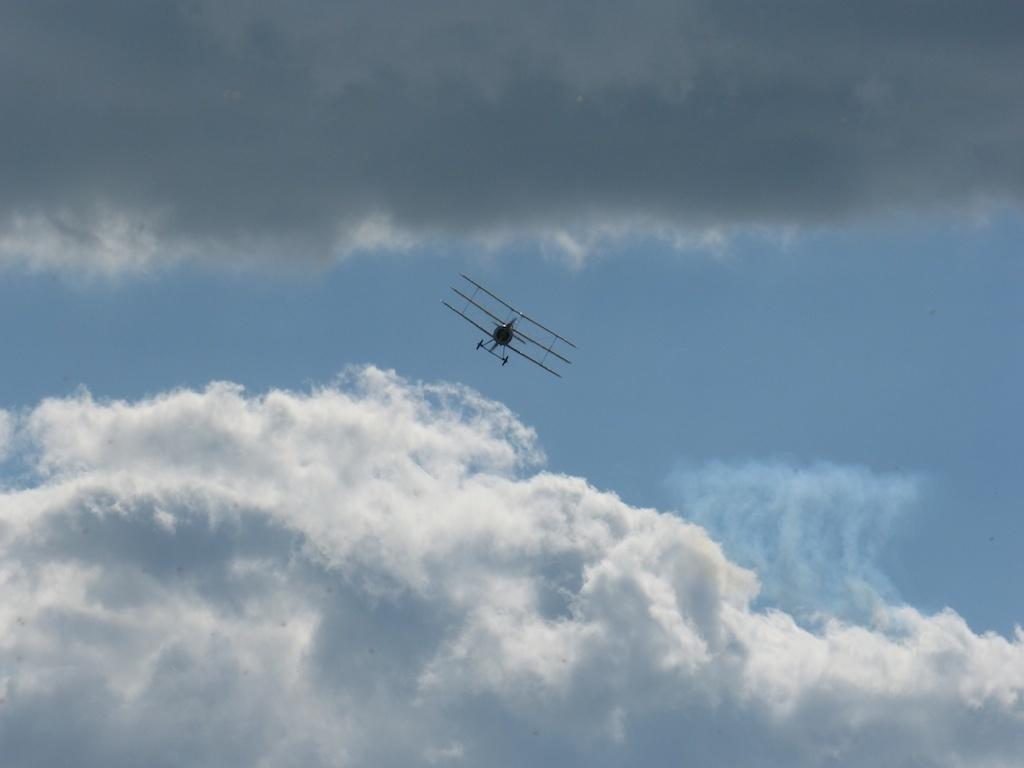What is the main subject of the image? The main subject of the image is a plane. Can you describe the plane's location in the image? The plane is in the air in the image. What can be seen in the background of the image? The sky is visible in the image. Are there any weather conditions depicted in the image? Yes, clouds are present in the sky. What type of scent can be detected coming from the plane in the image? There is no indication of any scent in the image, as it only features a plane in the air with clouds in the sky. 